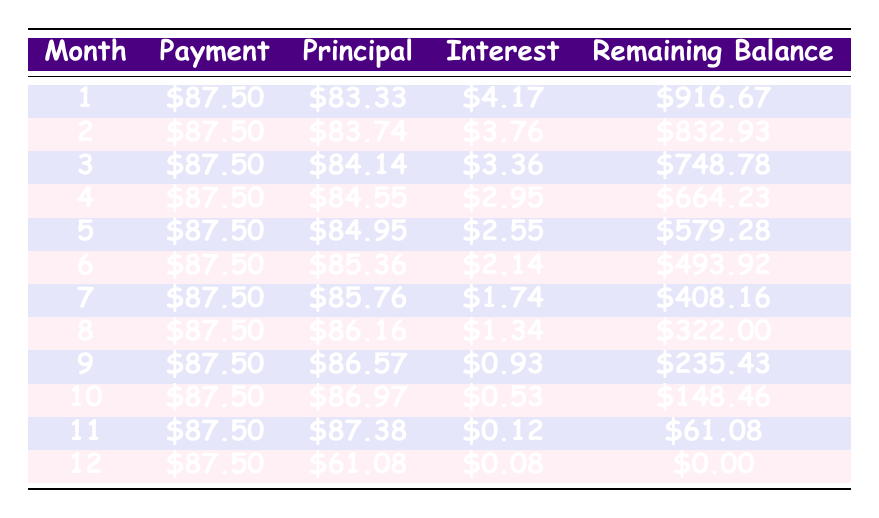What's the total payment in the first month? The total payment for the first month is directly listed in the table under the "Payment" column for month 1. It shows \$87.50.
Answer: 87.50 How much interest will I pay in the 6th month? The interest for the 6th month is specified in the table under the "Interest" column for month 6. It states \$2.14.
Answer: 2.14 What is my remaining balance after 4 months? The remaining balance after 4 months is presented in the table under the "Remaining Balance" column for month 4. It shows \$664.23.
Answer: 664.23 What's the total interest paid over the whole loan period? To calculate total interest, sum the interest payments from each month. Adding \$4.17, \$3.76, \$3.36, \$2.95, \$2.55, \$2.14, \$1.74, \$1.34, \$0.93, \$0.53, \$0.12, and \$0.08 gives a total of \$24.25.
Answer: 24.25 Is the principal payment in the 12th month higher than in the 5th month? In the table, the principal payment for the 12th month is \$61.08, and for the 5th month, it is \$84.95. Since \$61.08 is not higher than \$84.95, the answer is no.
Answer: No How much of my payment goes toward principal after 3 months? In the first three months, the principal payments are \$83.33 (month 1), \$83.74 (month 2), and \$84.14 (month 3). Adding these gives \$83.33 + \$83.74 + \$84.14 = \$251.21.
Answer: 251.21 What was the principal payment increase from month 1 to month 2? The principal payment for month 1 is \$83.33 and for month 2 is \$83.74. The difference is \$83.74 - \$83.33 = \$0.41, indicating an increase.
Answer: 0.41 Did my payments decrease as the months went on? The payments in the table stay consistent at \$87.50 for each month; thus, they did not decrease over time.
Answer: No What is the average remaining balance over the loan period? To find the average remaining balance, sum the remaining balance from all 12 months and divide by 12. The sum is \$916.67 + \$832.93 + \$748.78 + \$664.23 + \$579.28 + \$493.92 + \$408.16 + \$322.00 + \$235.43 + \$148.46 + \$61.08 + \$0.00 = \$4,103.44. Dividing by 12 gives \$4,103.44 / 12 = \$341.95.
Answer: 341.95 